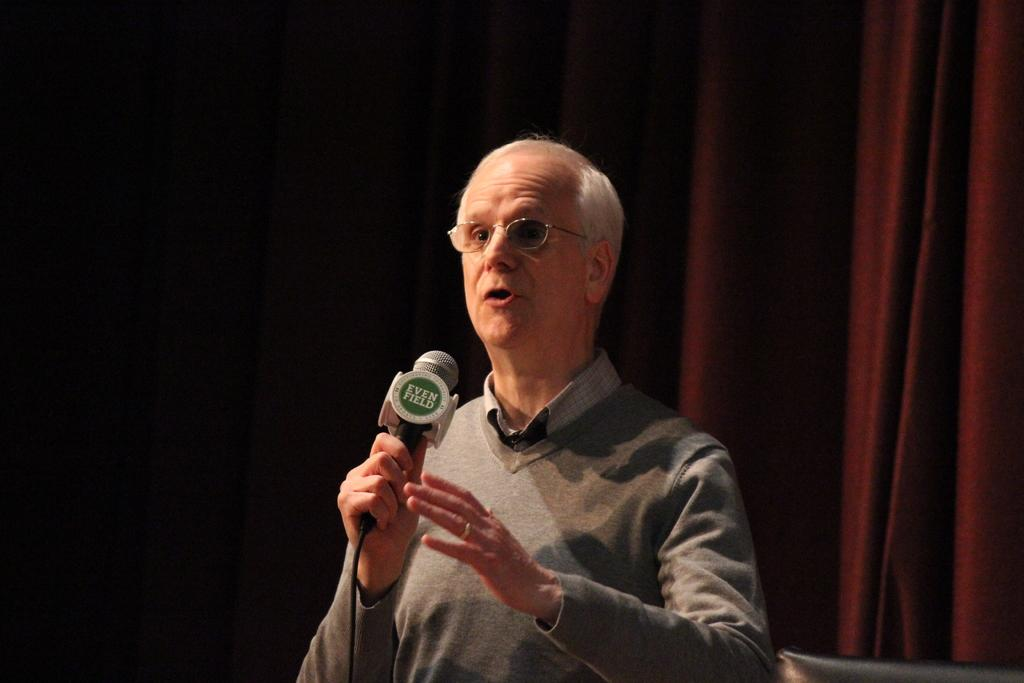What is the man in the image doing? The man is talking in the image. What is the man holding in the image? The man is holding a microphone in the image. What can be seen on the man's face in the image? The man is wearing spectacles in the image. What type of clothing is the man wearing in the image? The man is wearing a sweater in the image. What is the color of the curtain in the background of the image? The curtain in the background of the image is red. Can you see a volcano erupting in the background of the image? There is no volcano present in the image; it features a man holding a microphone and wearing a sweater, with a red curtain in the background. 